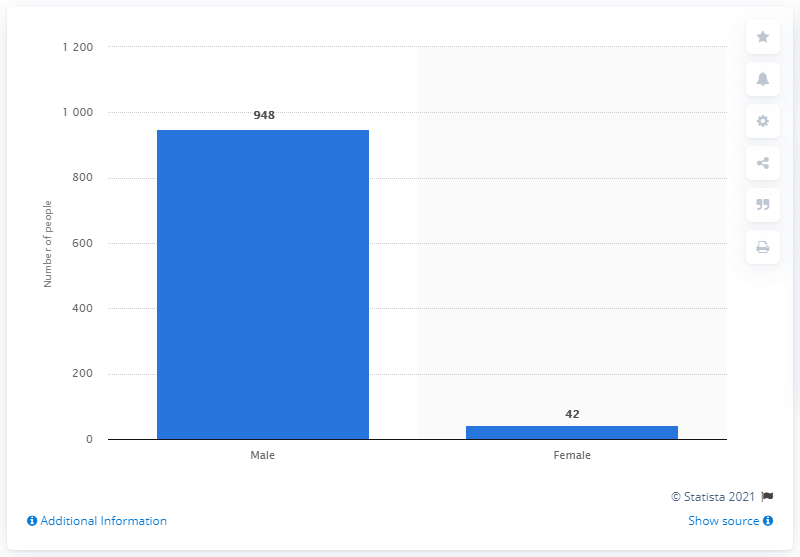Identify some key points in this picture. In 2015, a total of 948 men were killed by police in the United States. 